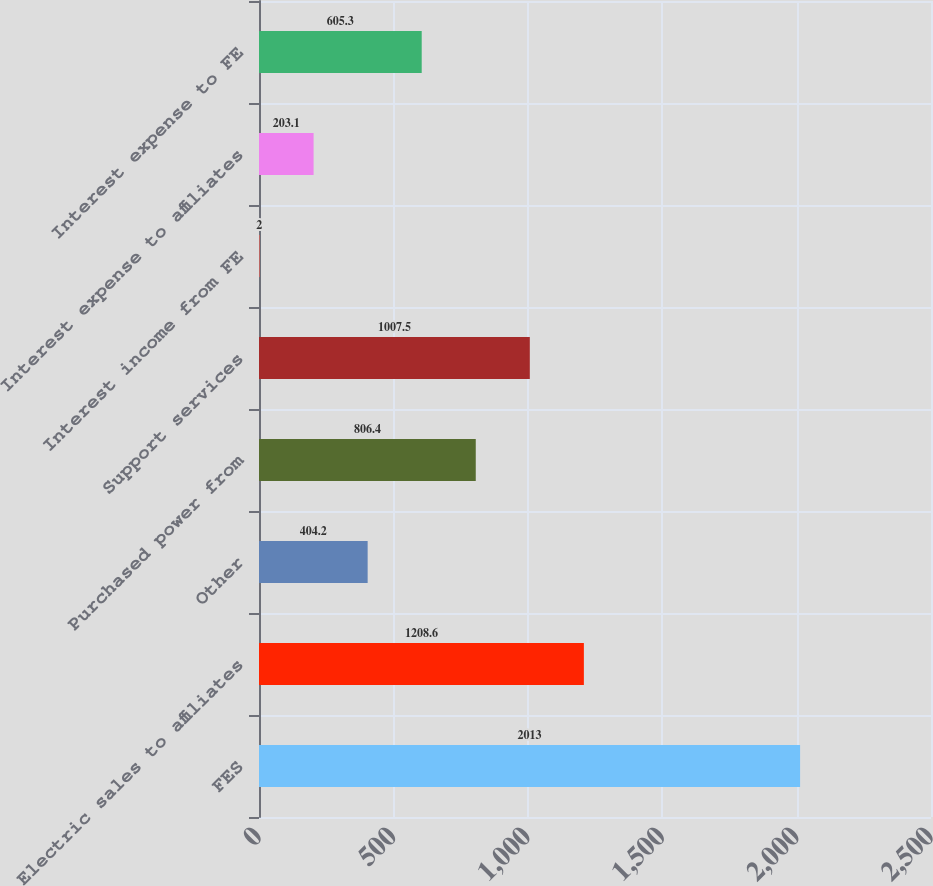Convert chart to OTSL. <chart><loc_0><loc_0><loc_500><loc_500><bar_chart><fcel>FES<fcel>Electric sales to affiliates<fcel>Other<fcel>Purchased power from<fcel>Support services<fcel>Interest income from FE<fcel>Interest expense to affiliates<fcel>Interest expense to FE<nl><fcel>2013<fcel>1208.6<fcel>404.2<fcel>806.4<fcel>1007.5<fcel>2<fcel>203.1<fcel>605.3<nl></chart> 